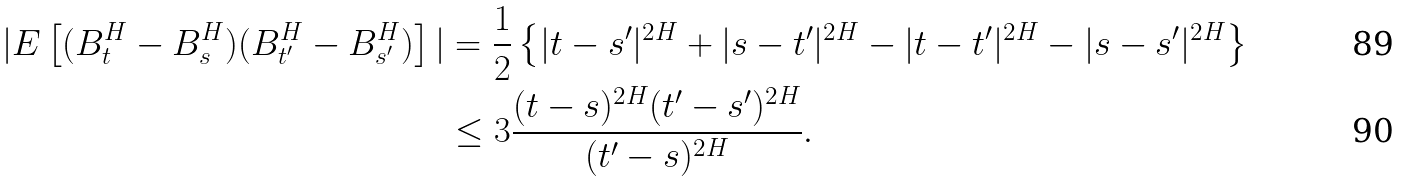Convert formula to latex. <formula><loc_0><loc_0><loc_500><loc_500>| E \left [ ( B ^ { H } _ { t } - B ^ { H } _ { s } ) ( B ^ { H } _ { t ^ { \prime } } - B ^ { H } _ { s ^ { \prime } } ) \right ] | & = \frac { 1 } { 2 } \left \{ | t - s ^ { \prime } | ^ { 2 H } + | s - t ^ { \prime } | ^ { 2 H } - | t - t ^ { \prime } | ^ { 2 H } - | s - s ^ { \prime } | ^ { 2 H } \right \} \\ & \leq 3 \frac { ( t - s ) ^ { 2 H } ( t ^ { \prime } - s ^ { \prime } ) ^ { 2 H } } { ( t ^ { \prime } - s ) ^ { 2 H } } .</formula> 